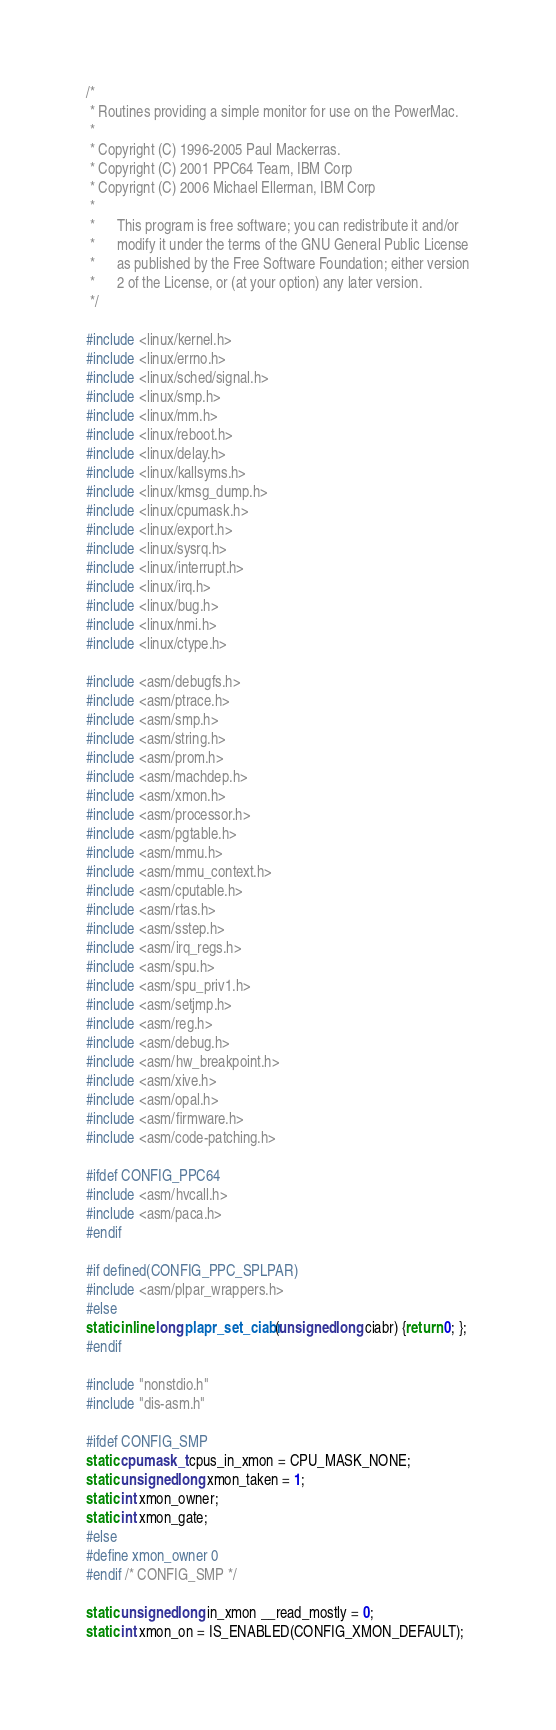Convert code to text. <code><loc_0><loc_0><loc_500><loc_500><_C_>/*
 * Routines providing a simple monitor for use on the PowerMac.
 *
 * Copyright (C) 1996-2005 Paul Mackerras.
 * Copyright (C) 2001 PPC64 Team, IBM Corp
 * Copyrignt (C) 2006 Michael Ellerman, IBM Corp
 *
 *      This program is free software; you can redistribute it and/or
 *      modify it under the terms of the GNU General Public License
 *      as published by the Free Software Foundation; either version
 *      2 of the License, or (at your option) any later version.
 */

#include <linux/kernel.h>
#include <linux/errno.h>
#include <linux/sched/signal.h>
#include <linux/smp.h>
#include <linux/mm.h>
#include <linux/reboot.h>
#include <linux/delay.h>
#include <linux/kallsyms.h>
#include <linux/kmsg_dump.h>
#include <linux/cpumask.h>
#include <linux/export.h>
#include <linux/sysrq.h>
#include <linux/interrupt.h>
#include <linux/irq.h>
#include <linux/bug.h>
#include <linux/nmi.h>
#include <linux/ctype.h>

#include <asm/debugfs.h>
#include <asm/ptrace.h>
#include <asm/smp.h>
#include <asm/string.h>
#include <asm/prom.h>
#include <asm/machdep.h>
#include <asm/xmon.h>
#include <asm/processor.h>
#include <asm/pgtable.h>
#include <asm/mmu.h>
#include <asm/mmu_context.h>
#include <asm/cputable.h>
#include <asm/rtas.h>
#include <asm/sstep.h>
#include <asm/irq_regs.h>
#include <asm/spu.h>
#include <asm/spu_priv1.h>
#include <asm/setjmp.h>
#include <asm/reg.h>
#include <asm/debug.h>
#include <asm/hw_breakpoint.h>
#include <asm/xive.h>
#include <asm/opal.h>
#include <asm/firmware.h>
#include <asm/code-patching.h>

#ifdef CONFIG_PPC64
#include <asm/hvcall.h>
#include <asm/paca.h>
#endif

#if defined(CONFIG_PPC_SPLPAR)
#include <asm/plpar_wrappers.h>
#else
static inline long plapr_set_ciabr(unsigned long ciabr) {return 0; };
#endif

#include "nonstdio.h"
#include "dis-asm.h"

#ifdef CONFIG_SMP
static cpumask_t cpus_in_xmon = CPU_MASK_NONE;
static unsigned long xmon_taken = 1;
static int xmon_owner;
static int xmon_gate;
#else
#define xmon_owner 0
#endif /* CONFIG_SMP */

static unsigned long in_xmon __read_mostly = 0;
static int xmon_on = IS_ENABLED(CONFIG_XMON_DEFAULT);
</code> 